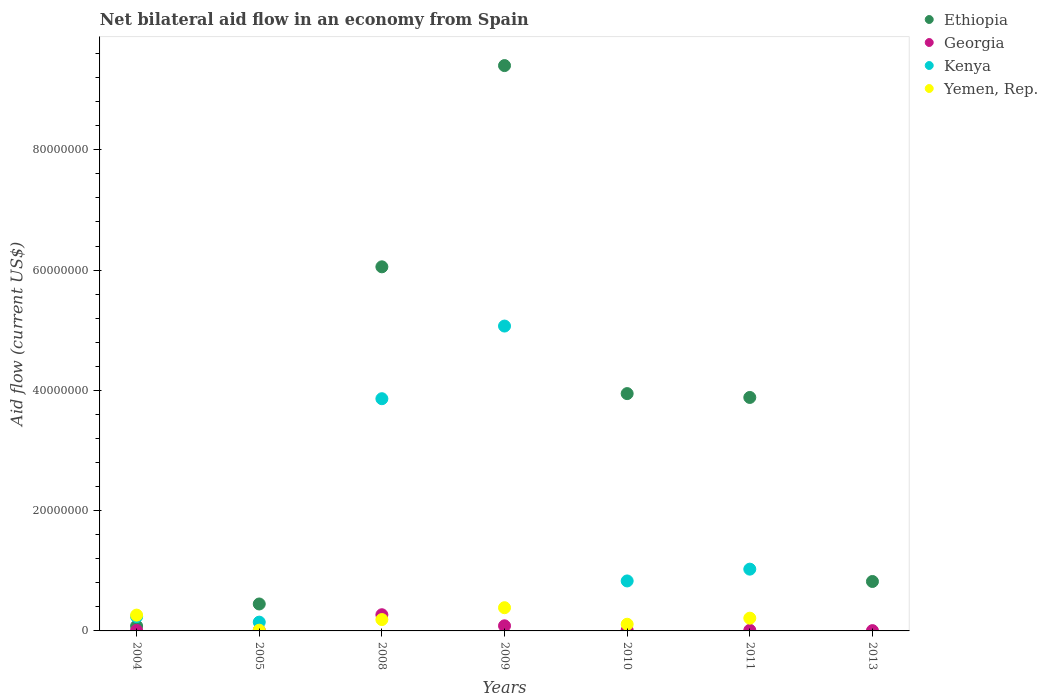Is the number of dotlines equal to the number of legend labels?
Keep it short and to the point. No. What is the net bilateral aid flow in Ethiopia in 2005?
Offer a very short reply. 4.48e+06. Across all years, what is the maximum net bilateral aid flow in Kenya?
Your answer should be compact. 5.07e+07. Across all years, what is the minimum net bilateral aid flow in Yemen, Rep.?
Your answer should be compact. 0. In which year was the net bilateral aid flow in Georgia maximum?
Offer a very short reply. 2008. What is the total net bilateral aid flow in Kenya in the graph?
Make the answer very short. 1.12e+08. What is the difference between the net bilateral aid flow in Kenya in 2004 and that in 2010?
Your answer should be very brief. -5.94e+06. What is the difference between the net bilateral aid flow in Ethiopia in 2004 and the net bilateral aid flow in Yemen, Rep. in 2009?
Your answer should be very brief. -3.05e+06. What is the average net bilateral aid flow in Ethiopia per year?
Ensure brevity in your answer.  3.52e+07. In the year 2008, what is the difference between the net bilateral aid flow in Kenya and net bilateral aid flow in Ethiopia?
Make the answer very short. -2.19e+07. What is the ratio of the net bilateral aid flow in Kenya in 2004 to that in 2010?
Your answer should be compact. 0.29. Is the difference between the net bilateral aid flow in Kenya in 2004 and 2008 greater than the difference between the net bilateral aid flow in Ethiopia in 2004 and 2008?
Your response must be concise. Yes. What is the difference between the highest and the second highest net bilateral aid flow in Kenya?
Provide a short and direct response. 1.21e+07. What is the difference between the highest and the lowest net bilateral aid flow in Ethiopia?
Your answer should be compact. 9.32e+07. Is the sum of the net bilateral aid flow in Georgia in 2005 and 2011 greater than the maximum net bilateral aid flow in Ethiopia across all years?
Your response must be concise. No. Is it the case that in every year, the sum of the net bilateral aid flow in Ethiopia and net bilateral aid flow in Yemen, Rep.  is greater than the sum of net bilateral aid flow in Kenya and net bilateral aid flow in Georgia?
Ensure brevity in your answer.  No. Does the net bilateral aid flow in Georgia monotonically increase over the years?
Your answer should be compact. No. Is the net bilateral aid flow in Yemen, Rep. strictly greater than the net bilateral aid flow in Georgia over the years?
Your answer should be compact. No. How many dotlines are there?
Your answer should be compact. 4. Does the graph contain grids?
Your answer should be compact. No. Where does the legend appear in the graph?
Your answer should be very brief. Top right. How are the legend labels stacked?
Keep it short and to the point. Vertical. What is the title of the graph?
Provide a succinct answer. Net bilateral aid flow in an economy from Spain. What is the Aid flow (current US$) of Ethiopia in 2004?
Ensure brevity in your answer.  8.10e+05. What is the Aid flow (current US$) of Kenya in 2004?
Provide a succinct answer. 2.37e+06. What is the Aid flow (current US$) of Yemen, Rep. in 2004?
Ensure brevity in your answer.  2.63e+06. What is the Aid flow (current US$) in Ethiopia in 2005?
Your answer should be very brief. 4.48e+06. What is the Aid flow (current US$) in Kenya in 2005?
Your response must be concise. 1.46e+06. What is the Aid flow (current US$) of Ethiopia in 2008?
Provide a succinct answer. 6.05e+07. What is the Aid flow (current US$) of Georgia in 2008?
Your answer should be compact. 2.69e+06. What is the Aid flow (current US$) of Kenya in 2008?
Provide a short and direct response. 3.86e+07. What is the Aid flow (current US$) in Yemen, Rep. in 2008?
Keep it short and to the point. 1.89e+06. What is the Aid flow (current US$) in Ethiopia in 2009?
Your response must be concise. 9.40e+07. What is the Aid flow (current US$) of Georgia in 2009?
Make the answer very short. 8.50e+05. What is the Aid flow (current US$) in Kenya in 2009?
Provide a succinct answer. 5.07e+07. What is the Aid flow (current US$) in Yemen, Rep. in 2009?
Your response must be concise. 3.86e+06. What is the Aid flow (current US$) in Ethiopia in 2010?
Offer a very short reply. 3.95e+07. What is the Aid flow (current US$) of Georgia in 2010?
Provide a succinct answer. 1.30e+05. What is the Aid flow (current US$) of Kenya in 2010?
Your response must be concise. 8.31e+06. What is the Aid flow (current US$) of Yemen, Rep. in 2010?
Your answer should be compact. 1.11e+06. What is the Aid flow (current US$) of Ethiopia in 2011?
Your answer should be compact. 3.88e+07. What is the Aid flow (current US$) in Georgia in 2011?
Provide a succinct answer. 1.10e+05. What is the Aid flow (current US$) in Kenya in 2011?
Your answer should be very brief. 1.03e+07. What is the Aid flow (current US$) of Yemen, Rep. in 2011?
Keep it short and to the point. 2.12e+06. What is the Aid flow (current US$) in Ethiopia in 2013?
Keep it short and to the point. 8.22e+06. What is the Aid flow (current US$) in Georgia in 2013?
Keep it short and to the point. 5.00e+04. What is the Aid flow (current US$) of Yemen, Rep. in 2013?
Provide a short and direct response. 0. Across all years, what is the maximum Aid flow (current US$) in Ethiopia?
Offer a very short reply. 9.40e+07. Across all years, what is the maximum Aid flow (current US$) of Georgia?
Ensure brevity in your answer.  2.69e+06. Across all years, what is the maximum Aid flow (current US$) in Kenya?
Ensure brevity in your answer.  5.07e+07. Across all years, what is the maximum Aid flow (current US$) of Yemen, Rep.?
Ensure brevity in your answer.  3.86e+06. Across all years, what is the minimum Aid flow (current US$) of Ethiopia?
Provide a succinct answer. 8.10e+05. Across all years, what is the minimum Aid flow (current US$) in Georgia?
Give a very brief answer. 5.00e+04. Across all years, what is the minimum Aid flow (current US$) of Yemen, Rep.?
Offer a terse response. 0. What is the total Aid flow (current US$) in Ethiopia in the graph?
Your answer should be very brief. 2.46e+08. What is the total Aid flow (current US$) of Georgia in the graph?
Make the answer very short. 4.02e+06. What is the total Aid flow (current US$) of Kenya in the graph?
Keep it short and to the point. 1.12e+08. What is the total Aid flow (current US$) in Yemen, Rep. in the graph?
Make the answer very short. 1.17e+07. What is the difference between the Aid flow (current US$) of Ethiopia in 2004 and that in 2005?
Ensure brevity in your answer.  -3.67e+06. What is the difference between the Aid flow (current US$) in Georgia in 2004 and that in 2005?
Offer a terse response. -10000. What is the difference between the Aid flow (current US$) in Kenya in 2004 and that in 2005?
Make the answer very short. 9.10e+05. What is the difference between the Aid flow (current US$) in Yemen, Rep. in 2004 and that in 2005?
Offer a terse response. 2.51e+06. What is the difference between the Aid flow (current US$) of Ethiopia in 2004 and that in 2008?
Your answer should be very brief. -5.97e+07. What is the difference between the Aid flow (current US$) of Georgia in 2004 and that in 2008?
Your answer should be very brief. -2.60e+06. What is the difference between the Aid flow (current US$) in Kenya in 2004 and that in 2008?
Provide a succinct answer. -3.62e+07. What is the difference between the Aid flow (current US$) of Yemen, Rep. in 2004 and that in 2008?
Give a very brief answer. 7.40e+05. What is the difference between the Aid flow (current US$) in Ethiopia in 2004 and that in 2009?
Make the answer very short. -9.32e+07. What is the difference between the Aid flow (current US$) in Georgia in 2004 and that in 2009?
Offer a very short reply. -7.60e+05. What is the difference between the Aid flow (current US$) in Kenya in 2004 and that in 2009?
Your response must be concise. -4.83e+07. What is the difference between the Aid flow (current US$) in Yemen, Rep. in 2004 and that in 2009?
Provide a succinct answer. -1.23e+06. What is the difference between the Aid flow (current US$) in Ethiopia in 2004 and that in 2010?
Your answer should be compact. -3.86e+07. What is the difference between the Aid flow (current US$) in Kenya in 2004 and that in 2010?
Give a very brief answer. -5.94e+06. What is the difference between the Aid flow (current US$) in Yemen, Rep. in 2004 and that in 2010?
Provide a short and direct response. 1.52e+06. What is the difference between the Aid flow (current US$) in Ethiopia in 2004 and that in 2011?
Give a very brief answer. -3.80e+07. What is the difference between the Aid flow (current US$) of Kenya in 2004 and that in 2011?
Provide a succinct answer. -7.90e+06. What is the difference between the Aid flow (current US$) of Yemen, Rep. in 2004 and that in 2011?
Make the answer very short. 5.10e+05. What is the difference between the Aid flow (current US$) in Ethiopia in 2004 and that in 2013?
Keep it short and to the point. -7.41e+06. What is the difference between the Aid flow (current US$) in Ethiopia in 2005 and that in 2008?
Offer a very short reply. -5.61e+07. What is the difference between the Aid flow (current US$) in Georgia in 2005 and that in 2008?
Provide a short and direct response. -2.59e+06. What is the difference between the Aid flow (current US$) of Kenya in 2005 and that in 2008?
Offer a terse response. -3.72e+07. What is the difference between the Aid flow (current US$) in Yemen, Rep. in 2005 and that in 2008?
Your answer should be very brief. -1.77e+06. What is the difference between the Aid flow (current US$) in Ethiopia in 2005 and that in 2009?
Provide a short and direct response. -8.95e+07. What is the difference between the Aid flow (current US$) of Georgia in 2005 and that in 2009?
Provide a succinct answer. -7.50e+05. What is the difference between the Aid flow (current US$) in Kenya in 2005 and that in 2009?
Make the answer very short. -4.92e+07. What is the difference between the Aid flow (current US$) in Yemen, Rep. in 2005 and that in 2009?
Make the answer very short. -3.74e+06. What is the difference between the Aid flow (current US$) of Ethiopia in 2005 and that in 2010?
Give a very brief answer. -3.50e+07. What is the difference between the Aid flow (current US$) of Kenya in 2005 and that in 2010?
Your response must be concise. -6.85e+06. What is the difference between the Aid flow (current US$) in Yemen, Rep. in 2005 and that in 2010?
Offer a terse response. -9.90e+05. What is the difference between the Aid flow (current US$) of Ethiopia in 2005 and that in 2011?
Give a very brief answer. -3.43e+07. What is the difference between the Aid flow (current US$) in Georgia in 2005 and that in 2011?
Your answer should be very brief. -10000. What is the difference between the Aid flow (current US$) in Kenya in 2005 and that in 2011?
Make the answer very short. -8.81e+06. What is the difference between the Aid flow (current US$) in Yemen, Rep. in 2005 and that in 2011?
Your response must be concise. -2.00e+06. What is the difference between the Aid flow (current US$) in Ethiopia in 2005 and that in 2013?
Your response must be concise. -3.74e+06. What is the difference between the Aid flow (current US$) in Ethiopia in 2008 and that in 2009?
Keep it short and to the point. -3.35e+07. What is the difference between the Aid flow (current US$) in Georgia in 2008 and that in 2009?
Offer a very short reply. 1.84e+06. What is the difference between the Aid flow (current US$) of Kenya in 2008 and that in 2009?
Provide a short and direct response. -1.21e+07. What is the difference between the Aid flow (current US$) of Yemen, Rep. in 2008 and that in 2009?
Give a very brief answer. -1.97e+06. What is the difference between the Aid flow (current US$) of Ethiopia in 2008 and that in 2010?
Your answer should be compact. 2.11e+07. What is the difference between the Aid flow (current US$) in Georgia in 2008 and that in 2010?
Make the answer very short. 2.56e+06. What is the difference between the Aid flow (current US$) of Kenya in 2008 and that in 2010?
Make the answer very short. 3.03e+07. What is the difference between the Aid flow (current US$) of Yemen, Rep. in 2008 and that in 2010?
Ensure brevity in your answer.  7.80e+05. What is the difference between the Aid flow (current US$) in Ethiopia in 2008 and that in 2011?
Provide a succinct answer. 2.17e+07. What is the difference between the Aid flow (current US$) of Georgia in 2008 and that in 2011?
Your answer should be very brief. 2.58e+06. What is the difference between the Aid flow (current US$) of Kenya in 2008 and that in 2011?
Your answer should be compact. 2.83e+07. What is the difference between the Aid flow (current US$) in Ethiopia in 2008 and that in 2013?
Offer a terse response. 5.23e+07. What is the difference between the Aid flow (current US$) in Georgia in 2008 and that in 2013?
Provide a short and direct response. 2.64e+06. What is the difference between the Aid flow (current US$) of Ethiopia in 2009 and that in 2010?
Offer a terse response. 5.45e+07. What is the difference between the Aid flow (current US$) of Georgia in 2009 and that in 2010?
Offer a terse response. 7.20e+05. What is the difference between the Aid flow (current US$) of Kenya in 2009 and that in 2010?
Offer a very short reply. 4.24e+07. What is the difference between the Aid flow (current US$) in Yemen, Rep. in 2009 and that in 2010?
Ensure brevity in your answer.  2.75e+06. What is the difference between the Aid flow (current US$) of Ethiopia in 2009 and that in 2011?
Ensure brevity in your answer.  5.52e+07. What is the difference between the Aid flow (current US$) in Georgia in 2009 and that in 2011?
Your answer should be very brief. 7.40e+05. What is the difference between the Aid flow (current US$) in Kenya in 2009 and that in 2011?
Ensure brevity in your answer.  4.04e+07. What is the difference between the Aid flow (current US$) in Yemen, Rep. in 2009 and that in 2011?
Your answer should be compact. 1.74e+06. What is the difference between the Aid flow (current US$) in Ethiopia in 2009 and that in 2013?
Your answer should be compact. 8.58e+07. What is the difference between the Aid flow (current US$) of Ethiopia in 2010 and that in 2011?
Offer a very short reply. 6.40e+05. What is the difference between the Aid flow (current US$) in Georgia in 2010 and that in 2011?
Keep it short and to the point. 2.00e+04. What is the difference between the Aid flow (current US$) of Kenya in 2010 and that in 2011?
Your response must be concise. -1.96e+06. What is the difference between the Aid flow (current US$) in Yemen, Rep. in 2010 and that in 2011?
Give a very brief answer. -1.01e+06. What is the difference between the Aid flow (current US$) in Ethiopia in 2010 and that in 2013?
Make the answer very short. 3.12e+07. What is the difference between the Aid flow (current US$) of Ethiopia in 2011 and that in 2013?
Keep it short and to the point. 3.06e+07. What is the difference between the Aid flow (current US$) of Ethiopia in 2004 and the Aid flow (current US$) of Georgia in 2005?
Your answer should be very brief. 7.10e+05. What is the difference between the Aid flow (current US$) of Ethiopia in 2004 and the Aid flow (current US$) of Kenya in 2005?
Your response must be concise. -6.50e+05. What is the difference between the Aid flow (current US$) in Ethiopia in 2004 and the Aid flow (current US$) in Yemen, Rep. in 2005?
Your answer should be very brief. 6.90e+05. What is the difference between the Aid flow (current US$) in Georgia in 2004 and the Aid flow (current US$) in Kenya in 2005?
Give a very brief answer. -1.37e+06. What is the difference between the Aid flow (current US$) of Georgia in 2004 and the Aid flow (current US$) of Yemen, Rep. in 2005?
Make the answer very short. -3.00e+04. What is the difference between the Aid flow (current US$) in Kenya in 2004 and the Aid flow (current US$) in Yemen, Rep. in 2005?
Your answer should be compact. 2.25e+06. What is the difference between the Aid flow (current US$) in Ethiopia in 2004 and the Aid flow (current US$) in Georgia in 2008?
Your answer should be compact. -1.88e+06. What is the difference between the Aid flow (current US$) of Ethiopia in 2004 and the Aid flow (current US$) of Kenya in 2008?
Ensure brevity in your answer.  -3.78e+07. What is the difference between the Aid flow (current US$) in Ethiopia in 2004 and the Aid flow (current US$) in Yemen, Rep. in 2008?
Provide a short and direct response. -1.08e+06. What is the difference between the Aid flow (current US$) of Georgia in 2004 and the Aid flow (current US$) of Kenya in 2008?
Give a very brief answer. -3.85e+07. What is the difference between the Aid flow (current US$) in Georgia in 2004 and the Aid flow (current US$) in Yemen, Rep. in 2008?
Provide a succinct answer. -1.80e+06. What is the difference between the Aid flow (current US$) of Ethiopia in 2004 and the Aid flow (current US$) of Kenya in 2009?
Give a very brief answer. -4.99e+07. What is the difference between the Aid flow (current US$) in Ethiopia in 2004 and the Aid flow (current US$) in Yemen, Rep. in 2009?
Your answer should be very brief. -3.05e+06. What is the difference between the Aid flow (current US$) of Georgia in 2004 and the Aid flow (current US$) of Kenya in 2009?
Your answer should be compact. -5.06e+07. What is the difference between the Aid flow (current US$) of Georgia in 2004 and the Aid flow (current US$) of Yemen, Rep. in 2009?
Make the answer very short. -3.77e+06. What is the difference between the Aid flow (current US$) in Kenya in 2004 and the Aid flow (current US$) in Yemen, Rep. in 2009?
Provide a short and direct response. -1.49e+06. What is the difference between the Aid flow (current US$) in Ethiopia in 2004 and the Aid flow (current US$) in Georgia in 2010?
Your response must be concise. 6.80e+05. What is the difference between the Aid flow (current US$) in Ethiopia in 2004 and the Aid flow (current US$) in Kenya in 2010?
Make the answer very short. -7.50e+06. What is the difference between the Aid flow (current US$) of Ethiopia in 2004 and the Aid flow (current US$) of Yemen, Rep. in 2010?
Provide a succinct answer. -3.00e+05. What is the difference between the Aid flow (current US$) in Georgia in 2004 and the Aid flow (current US$) in Kenya in 2010?
Your answer should be very brief. -8.22e+06. What is the difference between the Aid flow (current US$) of Georgia in 2004 and the Aid flow (current US$) of Yemen, Rep. in 2010?
Keep it short and to the point. -1.02e+06. What is the difference between the Aid flow (current US$) in Kenya in 2004 and the Aid flow (current US$) in Yemen, Rep. in 2010?
Ensure brevity in your answer.  1.26e+06. What is the difference between the Aid flow (current US$) of Ethiopia in 2004 and the Aid flow (current US$) of Kenya in 2011?
Your response must be concise. -9.46e+06. What is the difference between the Aid flow (current US$) of Ethiopia in 2004 and the Aid flow (current US$) of Yemen, Rep. in 2011?
Your answer should be very brief. -1.31e+06. What is the difference between the Aid flow (current US$) in Georgia in 2004 and the Aid flow (current US$) in Kenya in 2011?
Provide a short and direct response. -1.02e+07. What is the difference between the Aid flow (current US$) in Georgia in 2004 and the Aid flow (current US$) in Yemen, Rep. in 2011?
Provide a short and direct response. -2.03e+06. What is the difference between the Aid flow (current US$) of Kenya in 2004 and the Aid flow (current US$) of Yemen, Rep. in 2011?
Keep it short and to the point. 2.50e+05. What is the difference between the Aid flow (current US$) in Ethiopia in 2004 and the Aid flow (current US$) in Georgia in 2013?
Offer a very short reply. 7.60e+05. What is the difference between the Aid flow (current US$) of Ethiopia in 2005 and the Aid flow (current US$) of Georgia in 2008?
Give a very brief answer. 1.79e+06. What is the difference between the Aid flow (current US$) in Ethiopia in 2005 and the Aid flow (current US$) in Kenya in 2008?
Your response must be concise. -3.41e+07. What is the difference between the Aid flow (current US$) of Ethiopia in 2005 and the Aid flow (current US$) of Yemen, Rep. in 2008?
Make the answer very short. 2.59e+06. What is the difference between the Aid flow (current US$) of Georgia in 2005 and the Aid flow (current US$) of Kenya in 2008?
Your response must be concise. -3.85e+07. What is the difference between the Aid flow (current US$) in Georgia in 2005 and the Aid flow (current US$) in Yemen, Rep. in 2008?
Offer a terse response. -1.79e+06. What is the difference between the Aid flow (current US$) of Kenya in 2005 and the Aid flow (current US$) of Yemen, Rep. in 2008?
Keep it short and to the point. -4.30e+05. What is the difference between the Aid flow (current US$) in Ethiopia in 2005 and the Aid flow (current US$) in Georgia in 2009?
Your answer should be compact. 3.63e+06. What is the difference between the Aid flow (current US$) in Ethiopia in 2005 and the Aid flow (current US$) in Kenya in 2009?
Make the answer very short. -4.62e+07. What is the difference between the Aid flow (current US$) in Ethiopia in 2005 and the Aid flow (current US$) in Yemen, Rep. in 2009?
Give a very brief answer. 6.20e+05. What is the difference between the Aid flow (current US$) of Georgia in 2005 and the Aid flow (current US$) of Kenya in 2009?
Provide a succinct answer. -5.06e+07. What is the difference between the Aid flow (current US$) of Georgia in 2005 and the Aid flow (current US$) of Yemen, Rep. in 2009?
Provide a short and direct response. -3.76e+06. What is the difference between the Aid flow (current US$) in Kenya in 2005 and the Aid flow (current US$) in Yemen, Rep. in 2009?
Offer a very short reply. -2.40e+06. What is the difference between the Aid flow (current US$) in Ethiopia in 2005 and the Aid flow (current US$) in Georgia in 2010?
Provide a succinct answer. 4.35e+06. What is the difference between the Aid flow (current US$) of Ethiopia in 2005 and the Aid flow (current US$) of Kenya in 2010?
Your answer should be very brief. -3.83e+06. What is the difference between the Aid flow (current US$) in Ethiopia in 2005 and the Aid flow (current US$) in Yemen, Rep. in 2010?
Provide a short and direct response. 3.37e+06. What is the difference between the Aid flow (current US$) in Georgia in 2005 and the Aid flow (current US$) in Kenya in 2010?
Provide a short and direct response. -8.21e+06. What is the difference between the Aid flow (current US$) of Georgia in 2005 and the Aid flow (current US$) of Yemen, Rep. in 2010?
Offer a terse response. -1.01e+06. What is the difference between the Aid flow (current US$) in Ethiopia in 2005 and the Aid flow (current US$) in Georgia in 2011?
Give a very brief answer. 4.37e+06. What is the difference between the Aid flow (current US$) in Ethiopia in 2005 and the Aid flow (current US$) in Kenya in 2011?
Provide a short and direct response. -5.79e+06. What is the difference between the Aid flow (current US$) of Ethiopia in 2005 and the Aid flow (current US$) of Yemen, Rep. in 2011?
Your answer should be very brief. 2.36e+06. What is the difference between the Aid flow (current US$) in Georgia in 2005 and the Aid flow (current US$) in Kenya in 2011?
Offer a very short reply. -1.02e+07. What is the difference between the Aid flow (current US$) of Georgia in 2005 and the Aid flow (current US$) of Yemen, Rep. in 2011?
Your response must be concise. -2.02e+06. What is the difference between the Aid flow (current US$) of Kenya in 2005 and the Aid flow (current US$) of Yemen, Rep. in 2011?
Ensure brevity in your answer.  -6.60e+05. What is the difference between the Aid flow (current US$) of Ethiopia in 2005 and the Aid flow (current US$) of Georgia in 2013?
Keep it short and to the point. 4.43e+06. What is the difference between the Aid flow (current US$) in Ethiopia in 2008 and the Aid flow (current US$) in Georgia in 2009?
Your answer should be very brief. 5.97e+07. What is the difference between the Aid flow (current US$) of Ethiopia in 2008 and the Aid flow (current US$) of Kenya in 2009?
Your answer should be very brief. 9.85e+06. What is the difference between the Aid flow (current US$) of Ethiopia in 2008 and the Aid flow (current US$) of Yemen, Rep. in 2009?
Keep it short and to the point. 5.67e+07. What is the difference between the Aid flow (current US$) of Georgia in 2008 and the Aid flow (current US$) of Kenya in 2009?
Provide a succinct answer. -4.80e+07. What is the difference between the Aid flow (current US$) in Georgia in 2008 and the Aid flow (current US$) in Yemen, Rep. in 2009?
Make the answer very short. -1.17e+06. What is the difference between the Aid flow (current US$) of Kenya in 2008 and the Aid flow (current US$) of Yemen, Rep. in 2009?
Your answer should be very brief. 3.48e+07. What is the difference between the Aid flow (current US$) in Ethiopia in 2008 and the Aid flow (current US$) in Georgia in 2010?
Keep it short and to the point. 6.04e+07. What is the difference between the Aid flow (current US$) of Ethiopia in 2008 and the Aid flow (current US$) of Kenya in 2010?
Make the answer very short. 5.22e+07. What is the difference between the Aid flow (current US$) of Ethiopia in 2008 and the Aid flow (current US$) of Yemen, Rep. in 2010?
Offer a very short reply. 5.94e+07. What is the difference between the Aid flow (current US$) in Georgia in 2008 and the Aid flow (current US$) in Kenya in 2010?
Provide a succinct answer. -5.62e+06. What is the difference between the Aid flow (current US$) in Georgia in 2008 and the Aid flow (current US$) in Yemen, Rep. in 2010?
Offer a very short reply. 1.58e+06. What is the difference between the Aid flow (current US$) of Kenya in 2008 and the Aid flow (current US$) of Yemen, Rep. in 2010?
Your response must be concise. 3.75e+07. What is the difference between the Aid flow (current US$) of Ethiopia in 2008 and the Aid flow (current US$) of Georgia in 2011?
Your response must be concise. 6.04e+07. What is the difference between the Aid flow (current US$) of Ethiopia in 2008 and the Aid flow (current US$) of Kenya in 2011?
Your response must be concise. 5.03e+07. What is the difference between the Aid flow (current US$) of Ethiopia in 2008 and the Aid flow (current US$) of Yemen, Rep. in 2011?
Provide a short and direct response. 5.84e+07. What is the difference between the Aid flow (current US$) of Georgia in 2008 and the Aid flow (current US$) of Kenya in 2011?
Ensure brevity in your answer.  -7.58e+06. What is the difference between the Aid flow (current US$) in Georgia in 2008 and the Aid flow (current US$) in Yemen, Rep. in 2011?
Make the answer very short. 5.70e+05. What is the difference between the Aid flow (current US$) of Kenya in 2008 and the Aid flow (current US$) of Yemen, Rep. in 2011?
Offer a terse response. 3.65e+07. What is the difference between the Aid flow (current US$) of Ethiopia in 2008 and the Aid flow (current US$) of Georgia in 2013?
Keep it short and to the point. 6.05e+07. What is the difference between the Aid flow (current US$) of Ethiopia in 2009 and the Aid flow (current US$) of Georgia in 2010?
Your answer should be compact. 9.39e+07. What is the difference between the Aid flow (current US$) of Ethiopia in 2009 and the Aid flow (current US$) of Kenya in 2010?
Your answer should be very brief. 8.57e+07. What is the difference between the Aid flow (current US$) in Ethiopia in 2009 and the Aid flow (current US$) in Yemen, Rep. in 2010?
Offer a very short reply. 9.29e+07. What is the difference between the Aid flow (current US$) of Georgia in 2009 and the Aid flow (current US$) of Kenya in 2010?
Provide a short and direct response. -7.46e+06. What is the difference between the Aid flow (current US$) in Kenya in 2009 and the Aid flow (current US$) in Yemen, Rep. in 2010?
Offer a terse response. 4.96e+07. What is the difference between the Aid flow (current US$) in Ethiopia in 2009 and the Aid flow (current US$) in Georgia in 2011?
Your response must be concise. 9.39e+07. What is the difference between the Aid flow (current US$) of Ethiopia in 2009 and the Aid flow (current US$) of Kenya in 2011?
Your response must be concise. 8.37e+07. What is the difference between the Aid flow (current US$) in Ethiopia in 2009 and the Aid flow (current US$) in Yemen, Rep. in 2011?
Your answer should be compact. 9.19e+07. What is the difference between the Aid flow (current US$) in Georgia in 2009 and the Aid flow (current US$) in Kenya in 2011?
Give a very brief answer. -9.42e+06. What is the difference between the Aid flow (current US$) of Georgia in 2009 and the Aid flow (current US$) of Yemen, Rep. in 2011?
Provide a short and direct response. -1.27e+06. What is the difference between the Aid flow (current US$) of Kenya in 2009 and the Aid flow (current US$) of Yemen, Rep. in 2011?
Provide a succinct answer. 4.86e+07. What is the difference between the Aid flow (current US$) in Ethiopia in 2009 and the Aid flow (current US$) in Georgia in 2013?
Keep it short and to the point. 9.40e+07. What is the difference between the Aid flow (current US$) of Ethiopia in 2010 and the Aid flow (current US$) of Georgia in 2011?
Make the answer very short. 3.94e+07. What is the difference between the Aid flow (current US$) of Ethiopia in 2010 and the Aid flow (current US$) of Kenya in 2011?
Give a very brief answer. 2.92e+07. What is the difference between the Aid flow (current US$) of Ethiopia in 2010 and the Aid flow (current US$) of Yemen, Rep. in 2011?
Offer a very short reply. 3.73e+07. What is the difference between the Aid flow (current US$) in Georgia in 2010 and the Aid flow (current US$) in Kenya in 2011?
Ensure brevity in your answer.  -1.01e+07. What is the difference between the Aid flow (current US$) of Georgia in 2010 and the Aid flow (current US$) of Yemen, Rep. in 2011?
Provide a succinct answer. -1.99e+06. What is the difference between the Aid flow (current US$) in Kenya in 2010 and the Aid flow (current US$) in Yemen, Rep. in 2011?
Provide a succinct answer. 6.19e+06. What is the difference between the Aid flow (current US$) in Ethiopia in 2010 and the Aid flow (current US$) in Georgia in 2013?
Provide a short and direct response. 3.94e+07. What is the difference between the Aid flow (current US$) in Ethiopia in 2011 and the Aid flow (current US$) in Georgia in 2013?
Provide a short and direct response. 3.88e+07. What is the average Aid flow (current US$) in Ethiopia per year?
Offer a very short reply. 3.52e+07. What is the average Aid flow (current US$) in Georgia per year?
Your answer should be compact. 5.74e+05. What is the average Aid flow (current US$) in Kenya per year?
Offer a very short reply. 1.60e+07. What is the average Aid flow (current US$) of Yemen, Rep. per year?
Keep it short and to the point. 1.68e+06. In the year 2004, what is the difference between the Aid flow (current US$) of Ethiopia and Aid flow (current US$) of Georgia?
Your response must be concise. 7.20e+05. In the year 2004, what is the difference between the Aid flow (current US$) of Ethiopia and Aid flow (current US$) of Kenya?
Give a very brief answer. -1.56e+06. In the year 2004, what is the difference between the Aid flow (current US$) of Ethiopia and Aid flow (current US$) of Yemen, Rep.?
Ensure brevity in your answer.  -1.82e+06. In the year 2004, what is the difference between the Aid flow (current US$) in Georgia and Aid flow (current US$) in Kenya?
Keep it short and to the point. -2.28e+06. In the year 2004, what is the difference between the Aid flow (current US$) in Georgia and Aid flow (current US$) in Yemen, Rep.?
Give a very brief answer. -2.54e+06. In the year 2005, what is the difference between the Aid flow (current US$) in Ethiopia and Aid flow (current US$) in Georgia?
Offer a very short reply. 4.38e+06. In the year 2005, what is the difference between the Aid flow (current US$) in Ethiopia and Aid flow (current US$) in Kenya?
Offer a terse response. 3.02e+06. In the year 2005, what is the difference between the Aid flow (current US$) of Ethiopia and Aid flow (current US$) of Yemen, Rep.?
Offer a very short reply. 4.36e+06. In the year 2005, what is the difference between the Aid flow (current US$) of Georgia and Aid flow (current US$) of Kenya?
Provide a succinct answer. -1.36e+06. In the year 2005, what is the difference between the Aid flow (current US$) of Kenya and Aid flow (current US$) of Yemen, Rep.?
Provide a short and direct response. 1.34e+06. In the year 2008, what is the difference between the Aid flow (current US$) in Ethiopia and Aid flow (current US$) in Georgia?
Your answer should be compact. 5.78e+07. In the year 2008, what is the difference between the Aid flow (current US$) in Ethiopia and Aid flow (current US$) in Kenya?
Make the answer very short. 2.19e+07. In the year 2008, what is the difference between the Aid flow (current US$) in Ethiopia and Aid flow (current US$) in Yemen, Rep.?
Your answer should be very brief. 5.86e+07. In the year 2008, what is the difference between the Aid flow (current US$) of Georgia and Aid flow (current US$) of Kenya?
Provide a short and direct response. -3.59e+07. In the year 2008, what is the difference between the Aid flow (current US$) of Georgia and Aid flow (current US$) of Yemen, Rep.?
Your answer should be very brief. 8.00e+05. In the year 2008, what is the difference between the Aid flow (current US$) in Kenya and Aid flow (current US$) in Yemen, Rep.?
Give a very brief answer. 3.67e+07. In the year 2009, what is the difference between the Aid flow (current US$) of Ethiopia and Aid flow (current US$) of Georgia?
Offer a very short reply. 9.32e+07. In the year 2009, what is the difference between the Aid flow (current US$) of Ethiopia and Aid flow (current US$) of Kenya?
Your response must be concise. 4.33e+07. In the year 2009, what is the difference between the Aid flow (current US$) of Ethiopia and Aid flow (current US$) of Yemen, Rep.?
Ensure brevity in your answer.  9.01e+07. In the year 2009, what is the difference between the Aid flow (current US$) of Georgia and Aid flow (current US$) of Kenya?
Offer a terse response. -4.98e+07. In the year 2009, what is the difference between the Aid flow (current US$) in Georgia and Aid flow (current US$) in Yemen, Rep.?
Ensure brevity in your answer.  -3.01e+06. In the year 2009, what is the difference between the Aid flow (current US$) of Kenya and Aid flow (current US$) of Yemen, Rep.?
Offer a very short reply. 4.68e+07. In the year 2010, what is the difference between the Aid flow (current US$) of Ethiopia and Aid flow (current US$) of Georgia?
Offer a very short reply. 3.93e+07. In the year 2010, what is the difference between the Aid flow (current US$) of Ethiopia and Aid flow (current US$) of Kenya?
Give a very brief answer. 3.12e+07. In the year 2010, what is the difference between the Aid flow (current US$) in Ethiopia and Aid flow (current US$) in Yemen, Rep.?
Your response must be concise. 3.84e+07. In the year 2010, what is the difference between the Aid flow (current US$) in Georgia and Aid flow (current US$) in Kenya?
Provide a succinct answer. -8.18e+06. In the year 2010, what is the difference between the Aid flow (current US$) of Georgia and Aid flow (current US$) of Yemen, Rep.?
Provide a succinct answer. -9.80e+05. In the year 2010, what is the difference between the Aid flow (current US$) of Kenya and Aid flow (current US$) of Yemen, Rep.?
Keep it short and to the point. 7.20e+06. In the year 2011, what is the difference between the Aid flow (current US$) of Ethiopia and Aid flow (current US$) of Georgia?
Your answer should be compact. 3.87e+07. In the year 2011, what is the difference between the Aid flow (current US$) of Ethiopia and Aid flow (current US$) of Kenya?
Your answer should be compact. 2.86e+07. In the year 2011, what is the difference between the Aid flow (current US$) of Ethiopia and Aid flow (current US$) of Yemen, Rep.?
Offer a very short reply. 3.67e+07. In the year 2011, what is the difference between the Aid flow (current US$) of Georgia and Aid flow (current US$) of Kenya?
Your answer should be very brief. -1.02e+07. In the year 2011, what is the difference between the Aid flow (current US$) of Georgia and Aid flow (current US$) of Yemen, Rep.?
Offer a very short reply. -2.01e+06. In the year 2011, what is the difference between the Aid flow (current US$) of Kenya and Aid flow (current US$) of Yemen, Rep.?
Offer a terse response. 8.15e+06. In the year 2013, what is the difference between the Aid flow (current US$) in Ethiopia and Aid flow (current US$) in Georgia?
Ensure brevity in your answer.  8.17e+06. What is the ratio of the Aid flow (current US$) of Ethiopia in 2004 to that in 2005?
Your response must be concise. 0.18. What is the ratio of the Aid flow (current US$) of Georgia in 2004 to that in 2005?
Ensure brevity in your answer.  0.9. What is the ratio of the Aid flow (current US$) in Kenya in 2004 to that in 2005?
Make the answer very short. 1.62. What is the ratio of the Aid flow (current US$) of Yemen, Rep. in 2004 to that in 2005?
Keep it short and to the point. 21.92. What is the ratio of the Aid flow (current US$) of Ethiopia in 2004 to that in 2008?
Keep it short and to the point. 0.01. What is the ratio of the Aid flow (current US$) of Georgia in 2004 to that in 2008?
Offer a terse response. 0.03. What is the ratio of the Aid flow (current US$) of Kenya in 2004 to that in 2008?
Give a very brief answer. 0.06. What is the ratio of the Aid flow (current US$) of Yemen, Rep. in 2004 to that in 2008?
Keep it short and to the point. 1.39. What is the ratio of the Aid flow (current US$) of Ethiopia in 2004 to that in 2009?
Provide a short and direct response. 0.01. What is the ratio of the Aid flow (current US$) of Georgia in 2004 to that in 2009?
Your answer should be very brief. 0.11. What is the ratio of the Aid flow (current US$) in Kenya in 2004 to that in 2009?
Give a very brief answer. 0.05. What is the ratio of the Aid flow (current US$) in Yemen, Rep. in 2004 to that in 2009?
Ensure brevity in your answer.  0.68. What is the ratio of the Aid flow (current US$) in Ethiopia in 2004 to that in 2010?
Offer a very short reply. 0.02. What is the ratio of the Aid flow (current US$) of Georgia in 2004 to that in 2010?
Your answer should be very brief. 0.69. What is the ratio of the Aid flow (current US$) of Kenya in 2004 to that in 2010?
Offer a very short reply. 0.29. What is the ratio of the Aid flow (current US$) in Yemen, Rep. in 2004 to that in 2010?
Your answer should be very brief. 2.37. What is the ratio of the Aid flow (current US$) of Ethiopia in 2004 to that in 2011?
Provide a succinct answer. 0.02. What is the ratio of the Aid flow (current US$) in Georgia in 2004 to that in 2011?
Offer a very short reply. 0.82. What is the ratio of the Aid flow (current US$) of Kenya in 2004 to that in 2011?
Provide a short and direct response. 0.23. What is the ratio of the Aid flow (current US$) in Yemen, Rep. in 2004 to that in 2011?
Your answer should be very brief. 1.24. What is the ratio of the Aid flow (current US$) in Ethiopia in 2004 to that in 2013?
Your answer should be compact. 0.1. What is the ratio of the Aid flow (current US$) of Georgia in 2004 to that in 2013?
Provide a short and direct response. 1.8. What is the ratio of the Aid flow (current US$) of Ethiopia in 2005 to that in 2008?
Keep it short and to the point. 0.07. What is the ratio of the Aid flow (current US$) of Georgia in 2005 to that in 2008?
Offer a terse response. 0.04. What is the ratio of the Aid flow (current US$) in Kenya in 2005 to that in 2008?
Provide a succinct answer. 0.04. What is the ratio of the Aid flow (current US$) of Yemen, Rep. in 2005 to that in 2008?
Offer a very short reply. 0.06. What is the ratio of the Aid flow (current US$) in Ethiopia in 2005 to that in 2009?
Make the answer very short. 0.05. What is the ratio of the Aid flow (current US$) of Georgia in 2005 to that in 2009?
Your answer should be compact. 0.12. What is the ratio of the Aid flow (current US$) of Kenya in 2005 to that in 2009?
Your response must be concise. 0.03. What is the ratio of the Aid flow (current US$) of Yemen, Rep. in 2005 to that in 2009?
Your answer should be compact. 0.03. What is the ratio of the Aid flow (current US$) in Ethiopia in 2005 to that in 2010?
Provide a succinct answer. 0.11. What is the ratio of the Aid flow (current US$) in Georgia in 2005 to that in 2010?
Keep it short and to the point. 0.77. What is the ratio of the Aid flow (current US$) in Kenya in 2005 to that in 2010?
Offer a very short reply. 0.18. What is the ratio of the Aid flow (current US$) in Yemen, Rep. in 2005 to that in 2010?
Make the answer very short. 0.11. What is the ratio of the Aid flow (current US$) in Ethiopia in 2005 to that in 2011?
Offer a very short reply. 0.12. What is the ratio of the Aid flow (current US$) of Kenya in 2005 to that in 2011?
Keep it short and to the point. 0.14. What is the ratio of the Aid flow (current US$) in Yemen, Rep. in 2005 to that in 2011?
Make the answer very short. 0.06. What is the ratio of the Aid flow (current US$) of Ethiopia in 2005 to that in 2013?
Offer a terse response. 0.55. What is the ratio of the Aid flow (current US$) of Ethiopia in 2008 to that in 2009?
Provide a short and direct response. 0.64. What is the ratio of the Aid flow (current US$) in Georgia in 2008 to that in 2009?
Your answer should be compact. 3.16. What is the ratio of the Aid flow (current US$) of Kenya in 2008 to that in 2009?
Make the answer very short. 0.76. What is the ratio of the Aid flow (current US$) in Yemen, Rep. in 2008 to that in 2009?
Your response must be concise. 0.49. What is the ratio of the Aid flow (current US$) of Ethiopia in 2008 to that in 2010?
Your response must be concise. 1.53. What is the ratio of the Aid flow (current US$) in Georgia in 2008 to that in 2010?
Keep it short and to the point. 20.69. What is the ratio of the Aid flow (current US$) in Kenya in 2008 to that in 2010?
Your answer should be very brief. 4.65. What is the ratio of the Aid flow (current US$) of Yemen, Rep. in 2008 to that in 2010?
Offer a terse response. 1.7. What is the ratio of the Aid flow (current US$) in Ethiopia in 2008 to that in 2011?
Provide a short and direct response. 1.56. What is the ratio of the Aid flow (current US$) in Georgia in 2008 to that in 2011?
Your answer should be compact. 24.45. What is the ratio of the Aid flow (current US$) in Kenya in 2008 to that in 2011?
Keep it short and to the point. 3.76. What is the ratio of the Aid flow (current US$) of Yemen, Rep. in 2008 to that in 2011?
Offer a terse response. 0.89. What is the ratio of the Aid flow (current US$) in Ethiopia in 2008 to that in 2013?
Offer a very short reply. 7.37. What is the ratio of the Aid flow (current US$) of Georgia in 2008 to that in 2013?
Your answer should be compact. 53.8. What is the ratio of the Aid flow (current US$) of Ethiopia in 2009 to that in 2010?
Keep it short and to the point. 2.38. What is the ratio of the Aid flow (current US$) of Georgia in 2009 to that in 2010?
Keep it short and to the point. 6.54. What is the ratio of the Aid flow (current US$) of Kenya in 2009 to that in 2010?
Provide a succinct answer. 6.1. What is the ratio of the Aid flow (current US$) of Yemen, Rep. in 2009 to that in 2010?
Keep it short and to the point. 3.48. What is the ratio of the Aid flow (current US$) in Ethiopia in 2009 to that in 2011?
Provide a short and direct response. 2.42. What is the ratio of the Aid flow (current US$) in Georgia in 2009 to that in 2011?
Make the answer very short. 7.73. What is the ratio of the Aid flow (current US$) of Kenya in 2009 to that in 2011?
Make the answer very short. 4.94. What is the ratio of the Aid flow (current US$) in Yemen, Rep. in 2009 to that in 2011?
Give a very brief answer. 1.82. What is the ratio of the Aid flow (current US$) in Ethiopia in 2009 to that in 2013?
Ensure brevity in your answer.  11.44. What is the ratio of the Aid flow (current US$) in Ethiopia in 2010 to that in 2011?
Your answer should be compact. 1.02. What is the ratio of the Aid flow (current US$) of Georgia in 2010 to that in 2011?
Give a very brief answer. 1.18. What is the ratio of the Aid flow (current US$) in Kenya in 2010 to that in 2011?
Your response must be concise. 0.81. What is the ratio of the Aid flow (current US$) of Yemen, Rep. in 2010 to that in 2011?
Provide a succinct answer. 0.52. What is the ratio of the Aid flow (current US$) in Ethiopia in 2010 to that in 2013?
Ensure brevity in your answer.  4.8. What is the ratio of the Aid flow (current US$) in Ethiopia in 2011 to that in 2013?
Your answer should be very brief. 4.72. What is the difference between the highest and the second highest Aid flow (current US$) of Ethiopia?
Provide a short and direct response. 3.35e+07. What is the difference between the highest and the second highest Aid flow (current US$) in Georgia?
Provide a short and direct response. 1.84e+06. What is the difference between the highest and the second highest Aid flow (current US$) of Kenya?
Ensure brevity in your answer.  1.21e+07. What is the difference between the highest and the second highest Aid flow (current US$) of Yemen, Rep.?
Offer a terse response. 1.23e+06. What is the difference between the highest and the lowest Aid flow (current US$) in Ethiopia?
Your answer should be compact. 9.32e+07. What is the difference between the highest and the lowest Aid flow (current US$) in Georgia?
Your response must be concise. 2.64e+06. What is the difference between the highest and the lowest Aid flow (current US$) of Kenya?
Offer a very short reply. 5.07e+07. What is the difference between the highest and the lowest Aid flow (current US$) in Yemen, Rep.?
Make the answer very short. 3.86e+06. 